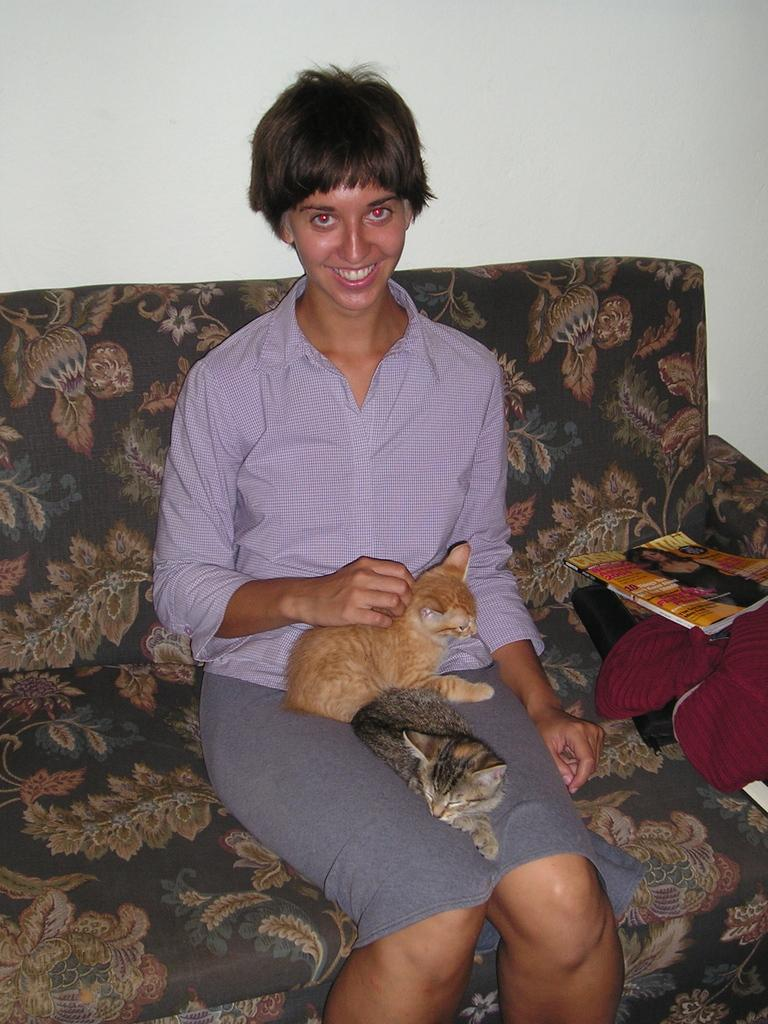Who is present in the image? There is a woman in the image. What is the woman doing in the image? The woman is sitting on a sofa. What is the woman holding in the image? The woman is holding two cats. What can be seen in the background of the image? There is a white wall in the background of the image. What else is on the sofa besides the woman? There is a book and a cloth on the sofa. What type of ticket is the woman holding in the image? There is no ticket present in the image; the woman is holding two cats. 